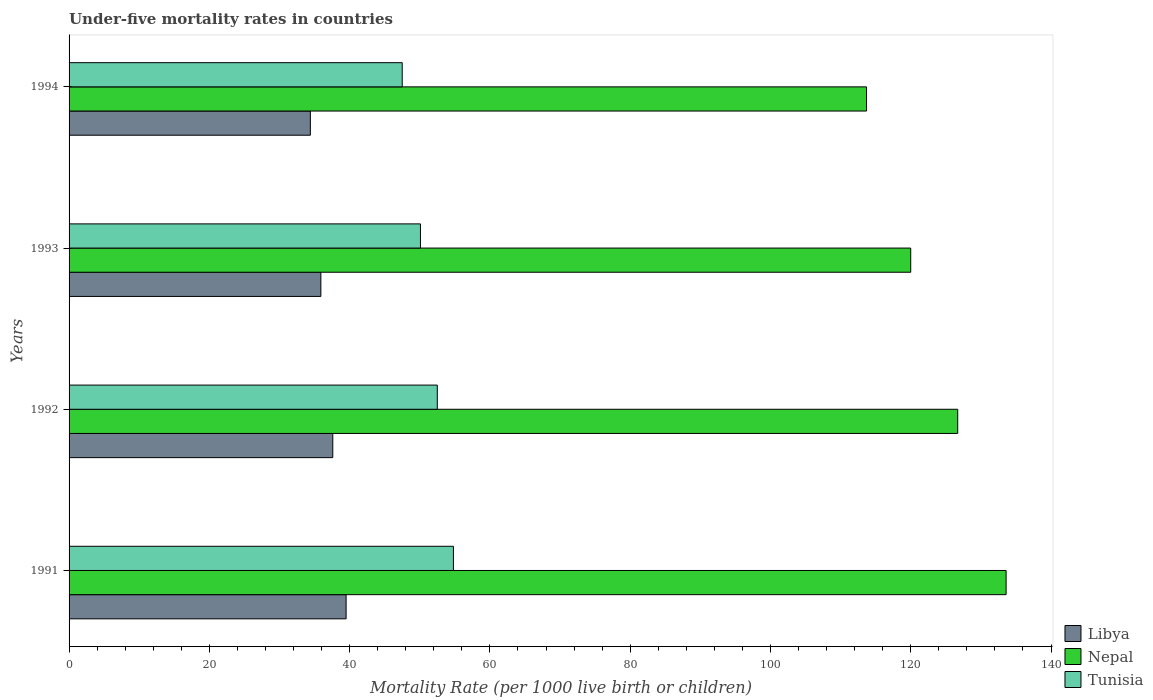Are the number of bars per tick equal to the number of legend labels?
Offer a very short reply. Yes. What is the under-five mortality rate in Nepal in 1994?
Offer a terse response. 113.7. Across all years, what is the maximum under-five mortality rate in Tunisia?
Provide a short and direct response. 54.8. Across all years, what is the minimum under-five mortality rate in Nepal?
Provide a short and direct response. 113.7. In which year was the under-five mortality rate in Libya minimum?
Your answer should be very brief. 1994. What is the total under-five mortality rate in Tunisia in the graph?
Provide a short and direct response. 204.9. What is the difference between the under-five mortality rate in Nepal in 1992 and that in 1994?
Offer a very short reply. 13. What is the difference between the under-five mortality rate in Libya in 1994 and the under-five mortality rate in Tunisia in 1991?
Offer a very short reply. -20.4. What is the average under-five mortality rate in Libya per year?
Your response must be concise. 36.85. In the year 1991, what is the difference between the under-five mortality rate in Tunisia and under-five mortality rate in Nepal?
Provide a succinct answer. -78.8. In how many years, is the under-five mortality rate in Nepal greater than 72 ?
Provide a short and direct response. 4. What is the ratio of the under-five mortality rate in Nepal in 1991 to that in 1994?
Ensure brevity in your answer.  1.18. What is the difference between the highest and the second highest under-five mortality rate in Libya?
Give a very brief answer. 1.9. What is the difference between the highest and the lowest under-five mortality rate in Libya?
Provide a succinct answer. 5.1. In how many years, is the under-five mortality rate in Tunisia greater than the average under-five mortality rate in Tunisia taken over all years?
Your answer should be compact. 2. Is the sum of the under-five mortality rate in Nepal in 1991 and 1994 greater than the maximum under-five mortality rate in Tunisia across all years?
Ensure brevity in your answer.  Yes. What does the 1st bar from the top in 1994 represents?
Keep it short and to the point. Tunisia. What does the 2nd bar from the bottom in 1991 represents?
Offer a terse response. Nepal. How many bars are there?
Your answer should be compact. 12. Are all the bars in the graph horizontal?
Your answer should be very brief. Yes. What is the difference between two consecutive major ticks on the X-axis?
Provide a succinct answer. 20. Are the values on the major ticks of X-axis written in scientific E-notation?
Your response must be concise. No. Does the graph contain grids?
Provide a short and direct response. No. What is the title of the graph?
Provide a succinct answer. Under-five mortality rates in countries. Does "Portugal" appear as one of the legend labels in the graph?
Provide a short and direct response. No. What is the label or title of the X-axis?
Make the answer very short. Mortality Rate (per 1000 live birth or children). What is the Mortality Rate (per 1000 live birth or children) in Libya in 1991?
Your response must be concise. 39.5. What is the Mortality Rate (per 1000 live birth or children) in Nepal in 1991?
Keep it short and to the point. 133.6. What is the Mortality Rate (per 1000 live birth or children) of Tunisia in 1991?
Offer a very short reply. 54.8. What is the Mortality Rate (per 1000 live birth or children) of Libya in 1992?
Make the answer very short. 37.6. What is the Mortality Rate (per 1000 live birth or children) in Nepal in 1992?
Provide a succinct answer. 126.7. What is the Mortality Rate (per 1000 live birth or children) in Tunisia in 1992?
Offer a very short reply. 52.5. What is the Mortality Rate (per 1000 live birth or children) in Libya in 1993?
Give a very brief answer. 35.9. What is the Mortality Rate (per 1000 live birth or children) of Nepal in 1993?
Your answer should be very brief. 120. What is the Mortality Rate (per 1000 live birth or children) of Tunisia in 1993?
Make the answer very short. 50.1. What is the Mortality Rate (per 1000 live birth or children) in Libya in 1994?
Make the answer very short. 34.4. What is the Mortality Rate (per 1000 live birth or children) of Nepal in 1994?
Make the answer very short. 113.7. What is the Mortality Rate (per 1000 live birth or children) in Tunisia in 1994?
Provide a short and direct response. 47.5. Across all years, what is the maximum Mortality Rate (per 1000 live birth or children) in Libya?
Provide a short and direct response. 39.5. Across all years, what is the maximum Mortality Rate (per 1000 live birth or children) of Nepal?
Provide a succinct answer. 133.6. Across all years, what is the maximum Mortality Rate (per 1000 live birth or children) in Tunisia?
Keep it short and to the point. 54.8. Across all years, what is the minimum Mortality Rate (per 1000 live birth or children) in Libya?
Make the answer very short. 34.4. Across all years, what is the minimum Mortality Rate (per 1000 live birth or children) in Nepal?
Your answer should be compact. 113.7. Across all years, what is the minimum Mortality Rate (per 1000 live birth or children) of Tunisia?
Your answer should be compact. 47.5. What is the total Mortality Rate (per 1000 live birth or children) in Libya in the graph?
Your answer should be very brief. 147.4. What is the total Mortality Rate (per 1000 live birth or children) in Nepal in the graph?
Your answer should be compact. 494. What is the total Mortality Rate (per 1000 live birth or children) in Tunisia in the graph?
Offer a terse response. 204.9. What is the difference between the Mortality Rate (per 1000 live birth or children) in Nepal in 1991 and that in 1992?
Offer a terse response. 6.9. What is the difference between the Mortality Rate (per 1000 live birth or children) of Tunisia in 1991 and that in 1992?
Your answer should be very brief. 2.3. What is the difference between the Mortality Rate (per 1000 live birth or children) of Nepal in 1991 and that in 1993?
Your response must be concise. 13.6. What is the difference between the Mortality Rate (per 1000 live birth or children) in Tunisia in 1991 and that in 1993?
Your response must be concise. 4.7. What is the difference between the Mortality Rate (per 1000 live birth or children) in Libya in 1991 and that in 1994?
Offer a very short reply. 5.1. What is the difference between the Mortality Rate (per 1000 live birth or children) in Nepal in 1991 and that in 1994?
Make the answer very short. 19.9. What is the difference between the Mortality Rate (per 1000 live birth or children) in Tunisia in 1991 and that in 1994?
Your answer should be compact. 7.3. What is the difference between the Mortality Rate (per 1000 live birth or children) of Libya in 1992 and that in 1993?
Ensure brevity in your answer.  1.7. What is the difference between the Mortality Rate (per 1000 live birth or children) of Nepal in 1992 and that in 1993?
Your answer should be very brief. 6.7. What is the difference between the Mortality Rate (per 1000 live birth or children) in Libya in 1992 and that in 1994?
Your answer should be very brief. 3.2. What is the difference between the Mortality Rate (per 1000 live birth or children) in Libya in 1993 and that in 1994?
Keep it short and to the point. 1.5. What is the difference between the Mortality Rate (per 1000 live birth or children) in Nepal in 1993 and that in 1994?
Your answer should be compact. 6.3. What is the difference between the Mortality Rate (per 1000 live birth or children) of Tunisia in 1993 and that in 1994?
Give a very brief answer. 2.6. What is the difference between the Mortality Rate (per 1000 live birth or children) in Libya in 1991 and the Mortality Rate (per 1000 live birth or children) in Nepal in 1992?
Offer a very short reply. -87.2. What is the difference between the Mortality Rate (per 1000 live birth or children) in Libya in 1991 and the Mortality Rate (per 1000 live birth or children) in Tunisia in 1992?
Provide a succinct answer. -13. What is the difference between the Mortality Rate (per 1000 live birth or children) of Nepal in 1991 and the Mortality Rate (per 1000 live birth or children) of Tunisia in 1992?
Provide a short and direct response. 81.1. What is the difference between the Mortality Rate (per 1000 live birth or children) in Libya in 1991 and the Mortality Rate (per 1000 live birth or children) in Nepal in 1993?
Make the answer very short. -80.5. What is the difference between the Mortality Rate (per 1000 live birth or children) in Libya in 1991 and the Mortality Rate (per 1000 live birth or children) in Tunisia in 1993?
Give a very brief answer. -10.6. What is the difference between the Mortality Rate (per 1000 live birth or children) in Nepal in 1991 and the Mortality Rate (per 1000 live birth or children) in Tunisia in 1993?
Provide a succinct answer. 83.5. What is the difference between the Mortality Rate (per 1000 live birth or children) in Libya in 1991 and the Mortality Rate (per 1000 live birth or children) in Nepal in 1994?
Your response must be concise. -74.2. What is the difference between the Mortality Rate (per 1000 live birth or children) in Libya in 1991 and the Mortality Rate (per 1000 live birth or children) in Tunisia in 1994?
Offer a very short reply. -8. What is the difference between the Mortality Rate (per 1000 live birth or children) of Nepal in 1991 and the Mortality Rate (per 1000 live birth or children) of Tunisia in 1994?
Your answer should be very brief. 86.1. What is the difference between the Mortality Rate (per 1000 live birth or children) of Libya in 1992 and the Mortality Rate (per 1000 live birth or children) of Nepal in 1993?
Offer a very short reply. -82.4. What is the difference between the Mortality Rate (per 1000 live birth or children) of Nepal in 1992 and the Mortality Rate (per 1000 live birth or children) of Tunisia in 1993?
Offer a very short reply. 76.6. What is the difference between the Mortality Rate (per 1000 live birth or children) in Libya in 1992 and the Mortality Rate (per 1000 live birth or children) in Nepal in 1994?
Your answer should be compact. -76.1. What is the difference between the Mortality Rate (per 1000 live birth or children) in Libya in 1992 and the Mortality Rate (per 1000 live birth or children) in Tunisia in 1994?
Provide a short and direct response. -9.9. What is the difference between the Mortality Rate (per 1000 live birth or children) of Nepal in 1992 and the Mortality Rate (per 1000 live birth or children) of Tunisia in 1994?
Your response must be concise. 79.2. What is the difference between the Mortality Rate (per 1000 live birth or children) of Libya in 1993 and the Mortality Rate (per 1000 live birth or children) of Nepal in 1994?
Keep it short and to the point. -77.8. What is the difference between the Mortality Rate (per 1000 live birth or children) of Nepal in 1993 and the Mortality Rate (per 1000 live birth or children) of Tunisia in 1994?
Your answer should be compact. 72.5. What is the average Mortality Rate (per 1000 live birth or children) of Libya per year?
Ensure brevity in your answer.  36.85. What is the average Mortality Rate (per 1000 live birth or children) in Nepal per year?
Your answer should be very brief. 123.5. What is the average Mortality Rate (per 1000 live birth or children) of Tunisia per year?
Ensure brevity in your answer.  51.23. In the year 1991, what is the difference between the Mortality Rate (per 1000 live birth or children) in Libya and Mortality Rate (per 1000 live birth or children) in Nepal?
Make the answer very short. -94.1. In the year 1991, what is the difference between the Mortality Rate (per 1000 live birth or children) in Libya and Mortality Rate (per 1000 live birth or children) in Tunisia?
Offer a very short reply. -15.3. In the year 1991, what is the difference between the Mortality Rate (per 1000 live birth or children) in Nepal and Mortality Rate (per 1000 live birth or children) in Tunisia?
Offer a very short reply. 78.8. In the year 1992, what is the difference between the Mortality Rate (per 1000 live birth or children) in Libya and Mortality Rate (per 1000 live birth or children) in Nepal?
Make the answer very short. -89.1. In the year 1992, what is the difference between the Mortality Rate (per 1000 live birth or children) of Libya and Mortality Rate (per 1000 live birth or children) of Tunisia?
Your answer should be compact. -14.9. In the year 1992, what is the difference between the Mortality Rate (per 1000 live birth or children) of Nepal and Mortality Rate (per 1000 live birth or children) of Tunisia?
Provide a short and direct response. 74.2. In the year 1993, what is the difference between the Mortality Rate (per 1000 live birth or children) of Libya and Mortality Rate (per 1000 live birth or children) of Nepal?
Provide a succinct answer. -84.1. In the year 1993, what is the difference between the Mortality Rate (per 1000 live birth or children) of Libya and Mortality Rate (per 1000 live birth or children) of Tunisia?
Provide a succinct answer. -14.2. In the year 1993, what is the difference between the Mortality Rate (per 1000 live birth or children) in Nepal and Mortality Rate (per 1000 live birth or children) in Tunisia?
Your answer should be compact. 69.9. In the year 1994, what is the difference between the Mortality Rate (per 1000 live birth or children) of Libya and Mortality Rate (per 1000 live birth or children) of Nepal?
Give a very brief answer. -79.3. In the year 1994, what is the difference between the Mortality Rate (per 1000 live birth or children) in Libya and Mortality Rate (per 1000 live birth or children) in Tunisia?
Provide a short and direct response. -13.1. In the year 1994, what is the difference between the Mortality Rate (per 1000 live birth or children) of Nepal and Mortality Rate (per 1000 live birth or children) of Tunisia?
Provide a succinct answer. 66.2. What is the ratio of the Mortality Rate (per 1000 live birth or children) in Libya in 1991 to that in 1992?
Ensure brevity in your answer.  1.05. What is the ratio of the Mortality Rate (per 1000 live birth or children) of Nepal in 1991 to that in 1992?
Your answer should be very brief. 1.05. What is the ratio of the Mortality Rate (per 1000 live birth or children) in Tunisia in 1991 to that in 1992?
Keep it short and to the point. 1.04. What is the ratio of the Mortality Rate (per 1000 live birth or children) in Libya in 1991 to that in 1993?
Ensure brevity in your answer.  1.1. What is the ratio of the Mortality Rate (per 1000 live birth or children) in Nepal in 1991 to that in 1993?
Provide a short and direct response. 1.11. What is the ratio of the Mortality Rate (per 1000 live birth or children) in Tunisia in 1991 to that in 1993?
Your response must be concise. 1.09. What is the ratio of the Mortality Rate (per 1000 live birth or children) of Libya in 1991 to that in 1994?
Provide a succinct answer. 1.15. What is the ratio of the Mortality Rate (per 1000 live birth or children) in Nepal in 1991 to that in 1994?
Ensure brevity in your answer.  1.18. What is the ratio of the Mortality Rate (per 1000 live birth or children) of Tunisia in 1991 to that in 1994?
Your response must be concise. 1.15. What is the ratio of the Mortality Rate (per 1000 live birth or children) in Libya in 1992 to that in 1993?
Make the answer very short. 1.05. What is the ratio of the Mortality Rate (per 1000 live birth or children) in Nepal in 1992 to that in 1993?
Provide a succinct answer. 1.06. What is the ratio of the Mortality Rate (per 1000 live birth or children) of Tunisia in 1992 to that in 1993?
Your answer should be very brief. 1.05. What is the ratio of the Mortality Rate (per 1000 live birth or children) in Libya in 1992 to that in 1994?
Offer a terse response. 1.09. What is the ratio of the Mortality Rate (per 1000 live birth or children) in Nepal in 1992 to that in 1994?
Offer a very short reply. 1.11. What is the ratio of the Mortality Rate (per 1000 live birth or children) in Tunisia in 1992 to that in 1994?
Your answer should be very brief. 1.11. What is the ratio of the Mortality Rate (per 1000 live birth or children) in Libya in 1993 to that in 1994?
Offer a very short reply. 1.04. What is the ratio of the Mortality Rate (per 1000 live birth or children) of Nepal in 1993 to that in 1994?
Provide a short and direct response. 1.06. What is the ratio of the Mortality Rate (per 1000 live birth or children) in Tunisia in 1993 to that in 1994?
Give a very brief answer. 1.05. What is the difference between the highest and the second highest Mortality Rate (per 1000 live birth or children) in Libya?
Your answer should be very brief. 1.9. What is the difference between the highest and the second highest Mortality Rate (per 1000 live birth or children) of Nepal?
Ensure brevity in your answer.  6.9. 